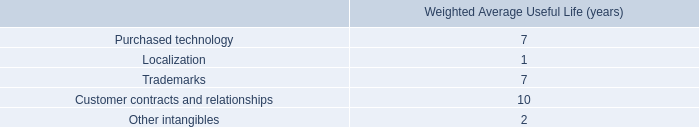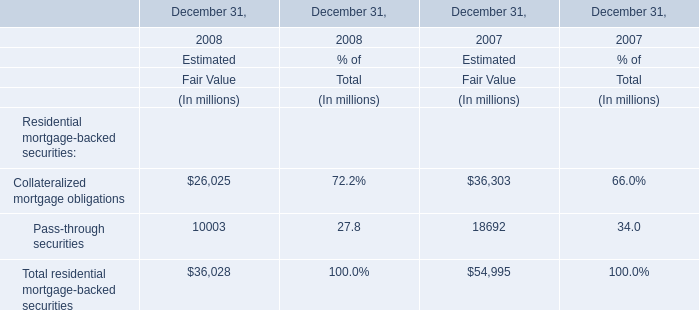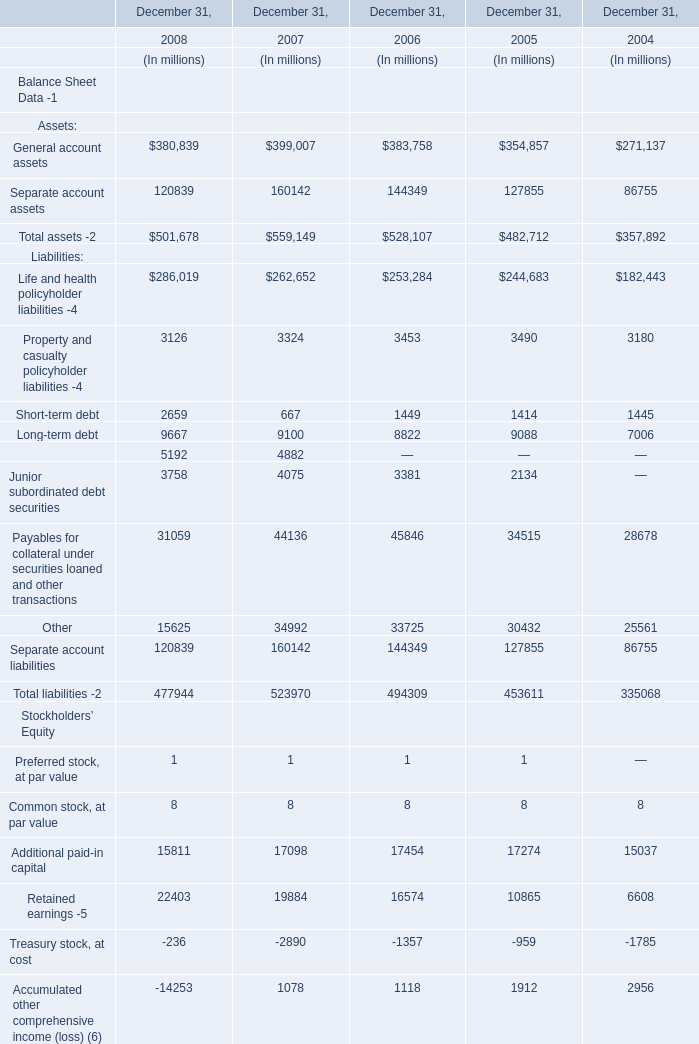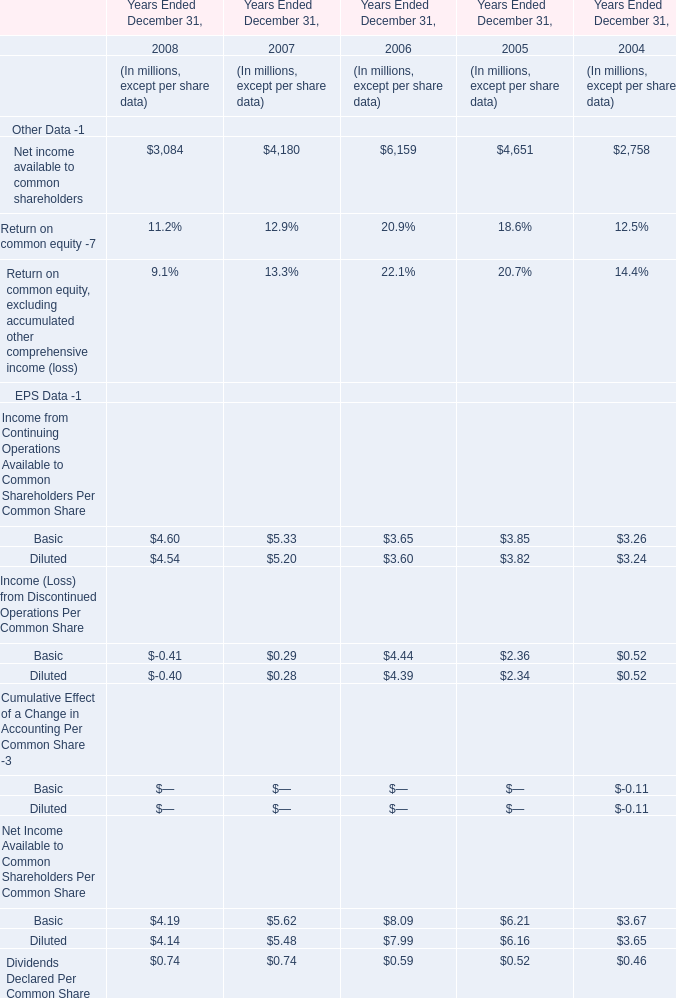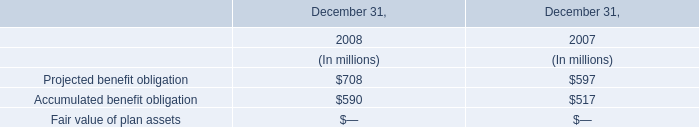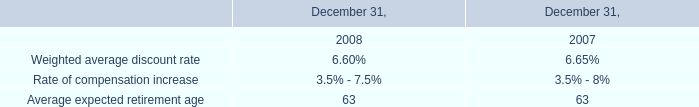How many Income (Loss) from Discontinued Operations Per Common Share exceed the average of Income (Loss) from Discontinued Operations Per Common Share in 2006? 
Answer: 1. 